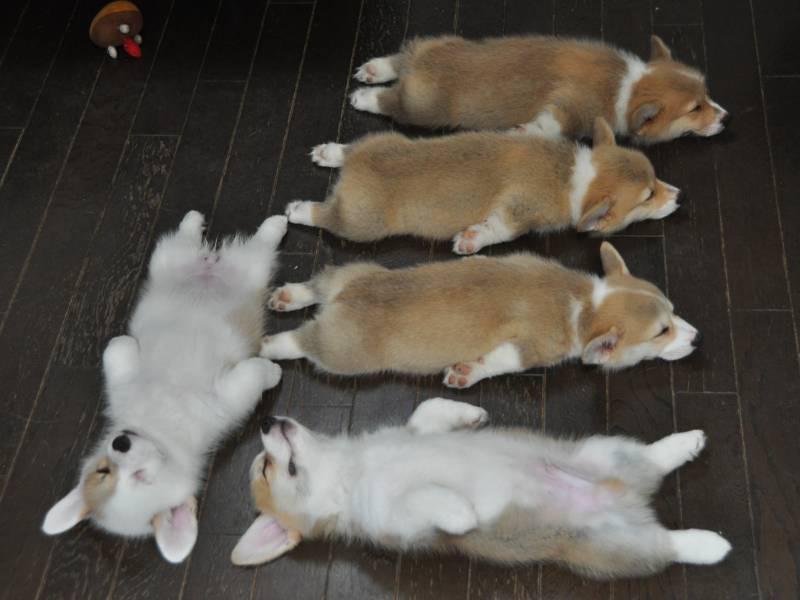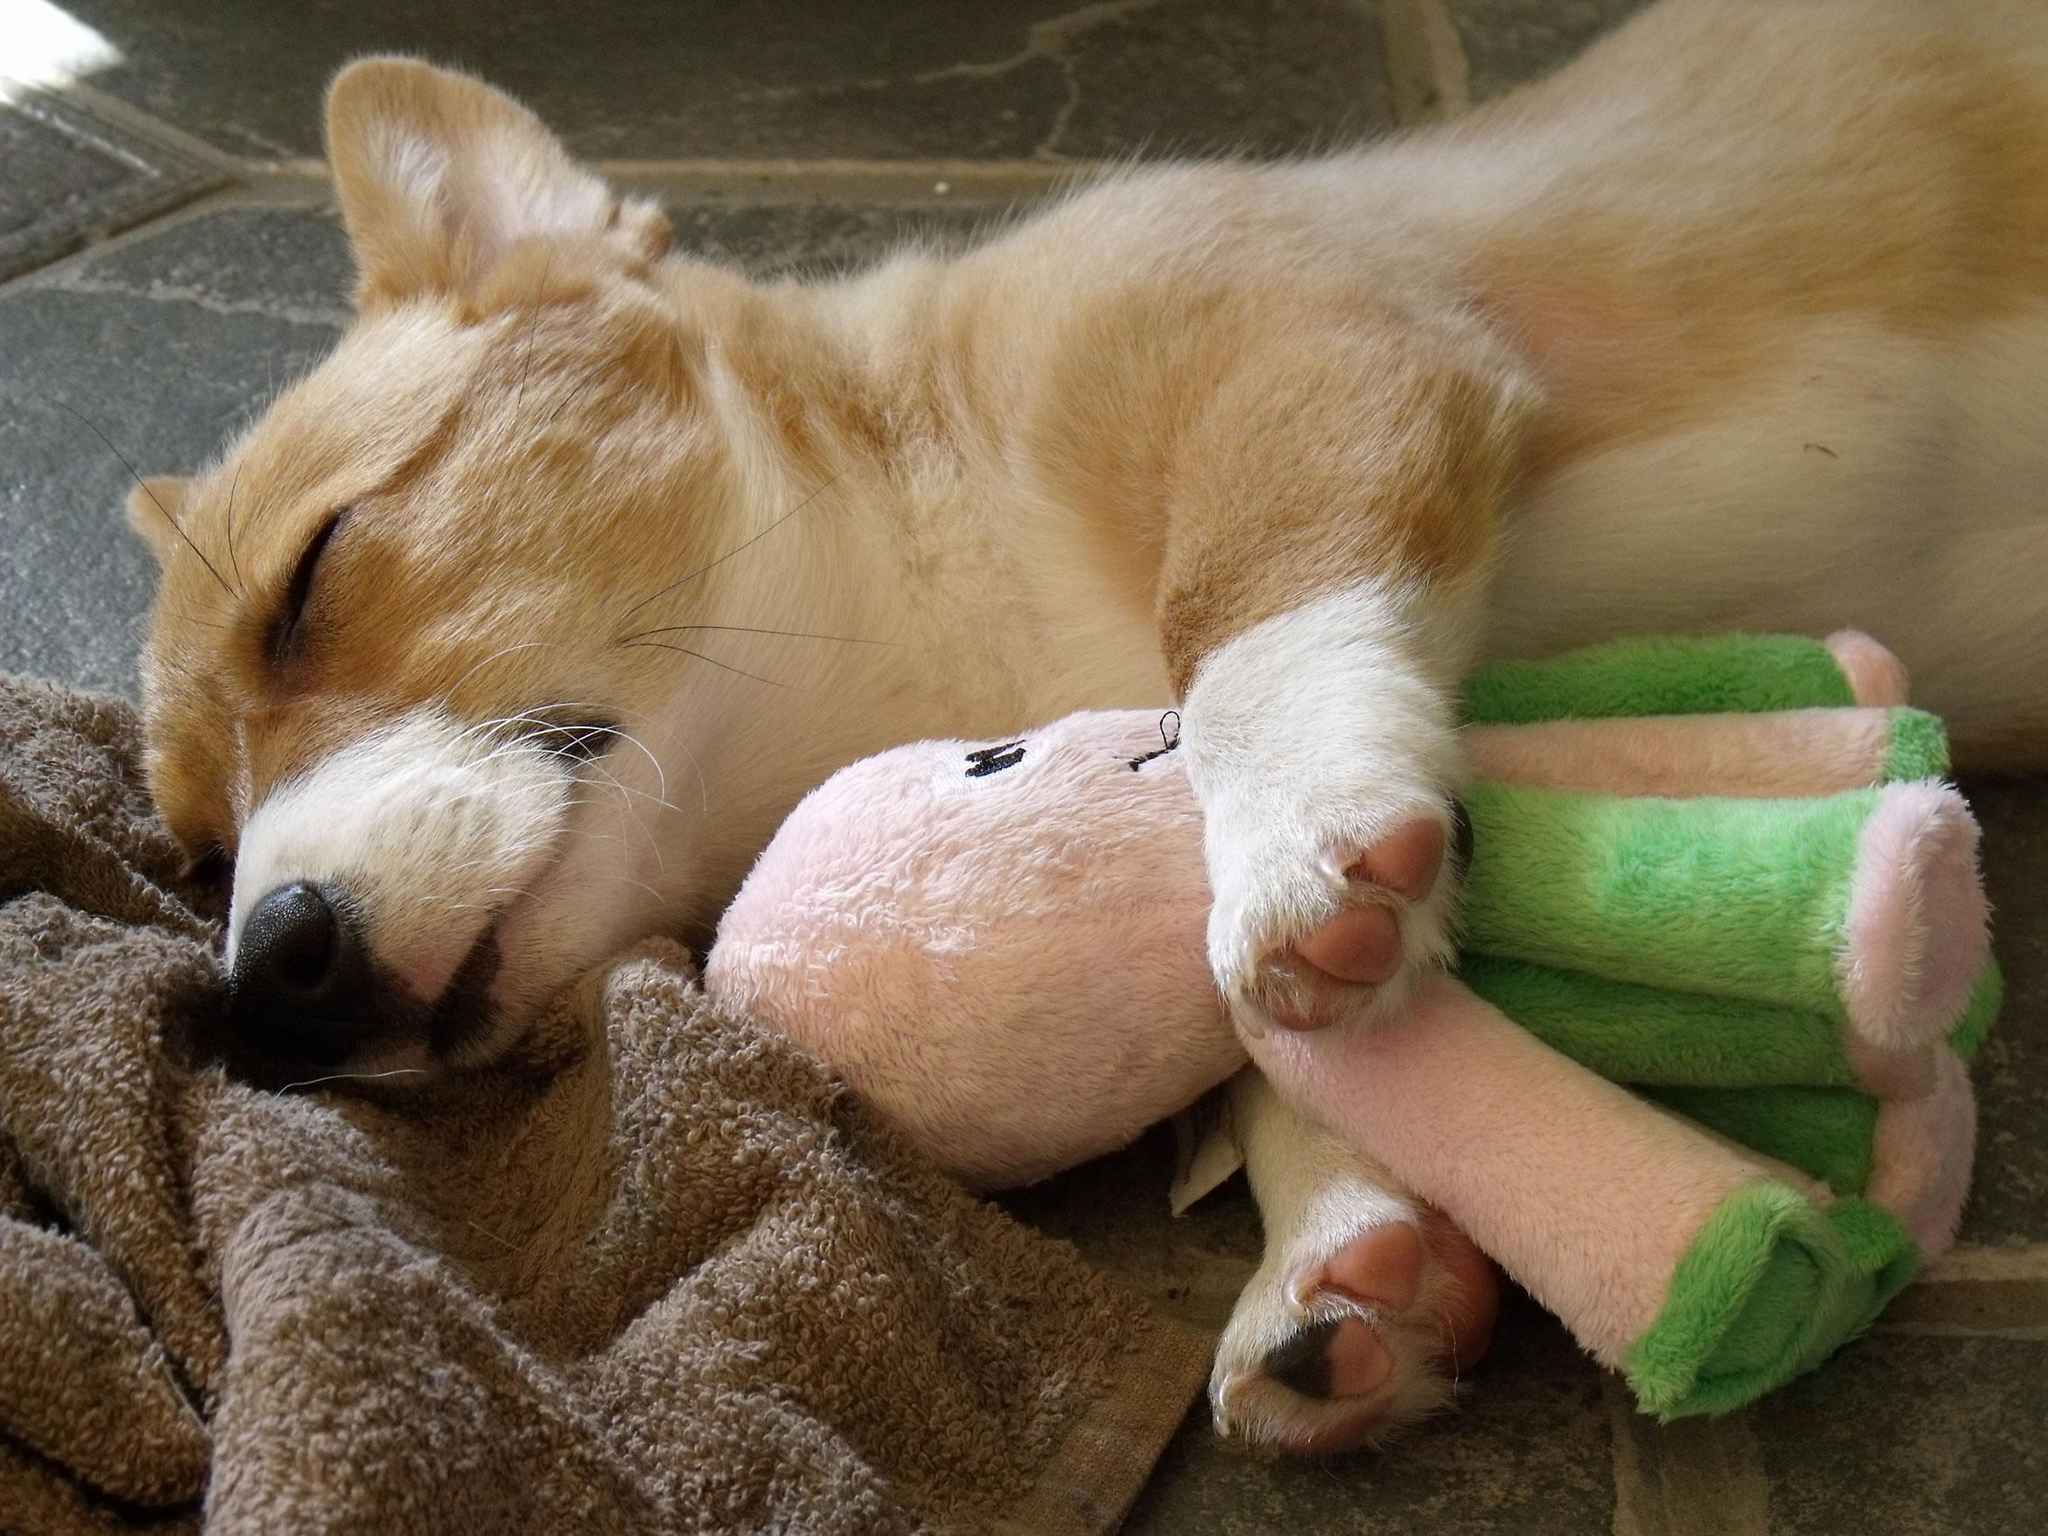The first image is the image on the left, the second image is the image on the right. Evaluate the accuracy of this statement regarding the images: "There is at least one dog lying on its front or back.". Is it true? Answer yes or no. Yes. 